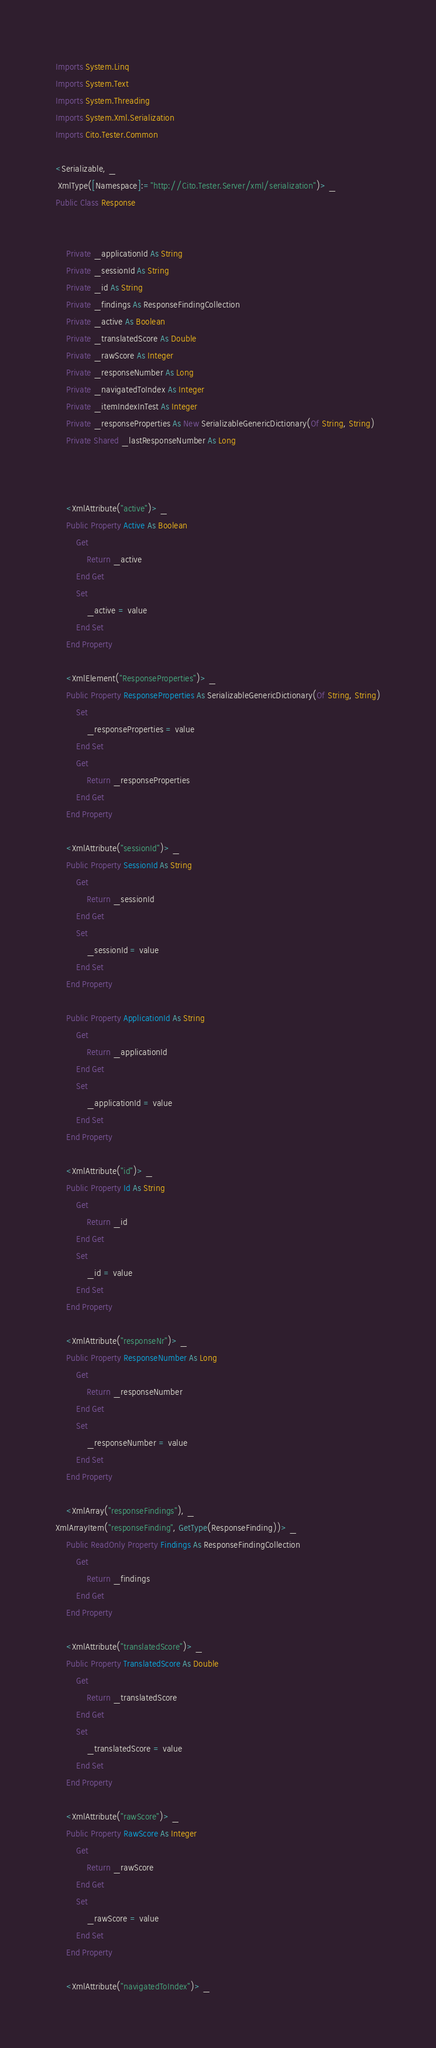Convert code to text. <code><loc_0><loc_0><loc_500><loc_500><_VisualBasic_>
Imports System.Linq
Imports System.Text
Imports System.Threading
Imports System.Xml.Serialization
Imports Cito.Tester.Common

<Serializable, _
 XmlType([Namespace]:="http://Cito.Tester.Server/xml/serialization")> _
Public Class Response


    Private _applicationId As String
    Private _sessionId As String
    Private _id As String
    Private _findings As ResponseFindingCollection
    Private _active As Boolean
    Private _translatedScore As Double
    Private _rawScore As Integer
    Private _responseNumber As Long
    Private _navigatedToIndex As Integer
    Private _itemIndexInTest As Integer
    Private _responseProperties As New SerializableGenericDictionary(Of String, String)
    Private Shared _lastResponseNumber As Long



    <XmlAttribute("active")> _
    Public Property Active As Boolean
        Get
            Return _active
        End Get
        Set
            _active = value
        End Set
    End Property

    <XmlElement("ResponseProperties")> _
    Public Property ResponseProperties As SerializableGenericDictionary(Of String, String)
        Set
            _responseProperties = value
        End Set
        Get
            Return _responseProperties
        End Get
    End Property

    <XmlAttribute("sessionId")> _
    Public Property SessionId As String
        Get
            Return _sessionId
        End Get
        Set
            _sessionId = value
        End Set
    End Property

    Public Property ApplicationId As String
        Get
            Return _applicationId
        End Get
        Set
            _applicationId = value
        End Set
    End Property

    <XmlAttribute("id")> _
    Public Property Id As String
        Get
            Return _id
        End Get
        Set
            _id = value
        End Set
    End Property

    <XmlAttribute("responseNr")> _
    Public Property ResponseNumber As Long
        Get
            Return _responseNumber
        End Get
        Set
            _responseNumber = value
        End Set
    End Property

    <XmlArray("responseFindings"), _
XmlArrayItem("responseFinding", GetType(ResponseFinding))> _
    Public ReadOnly Property Findings As ResponseFindingCollection
        Get
            Return _findings
        End Get
    End Property

    <XmlAttribute("translatedScore")> _
    Public Property TranslatedScore As Double
        Get
            Return _translatedScore
        End Get
        Set
            _translatedScore = value
        End Set
    End Property

    <XmlAttribute("rawScore")> _
    Public Property RawScore As Integer
        Get
            Return _rawScore
        End Get
        Set
            _rawScore = value
        End Set
    End Property

    <XmlAttribute("navigatedToIndex")> _</code> 